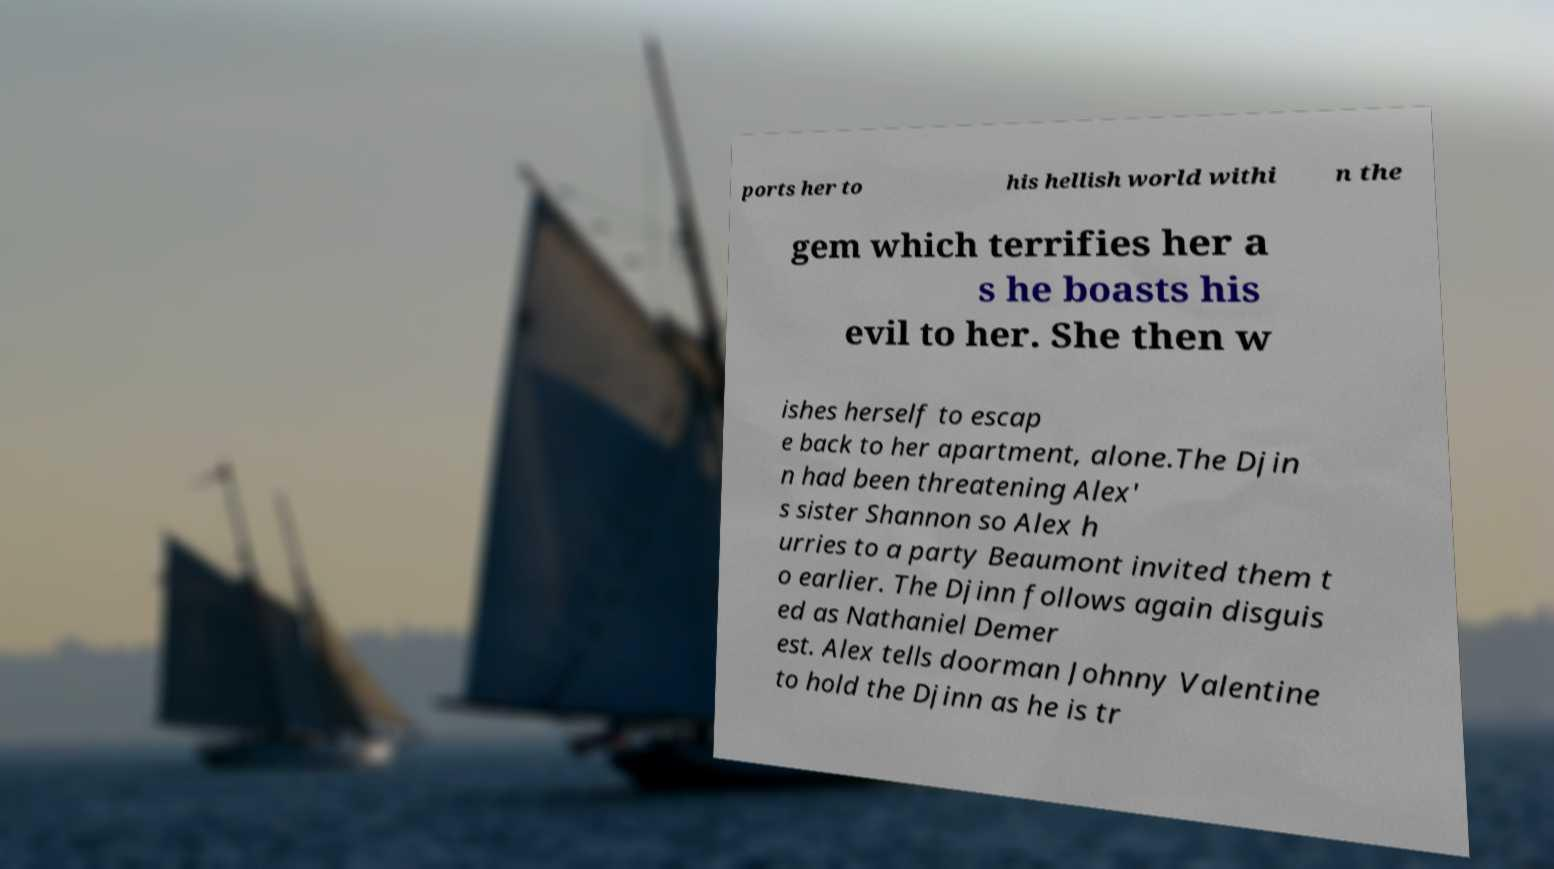Please identify and transcribe the text found in this image. ports her to his hellish world withi n the gem which terrifies her a s he boasts his evil to her. She then w ishes herself to escap e back to her apartment, alone.The Djin n had been threatening Alex' s sister Shannon so Alex h urries to a party Beaumont invited them t o earlier. The Djinn follows again disguis ed as Nathaniel Demer est. Alex tells doorman Johnny Valentine to hold the Djinn as he is tr 